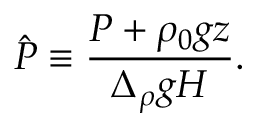Convert formula to latex. <formula><loc_0><loc_0><loc_500><loc_500>\hat { P } \equiv \frac { P + \rho _ { 0 } g z } { \Delta _ { \rho } g H } .</formula> 